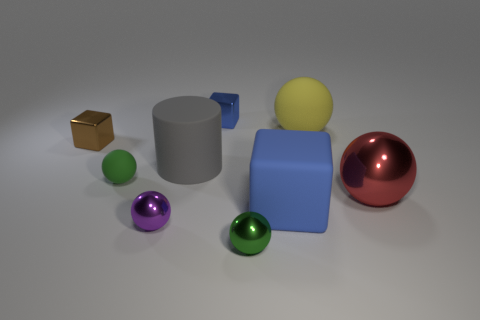Subtract all big blue matte cubes. How many cubes are left? 2 Subtract all blue blocks. How many blocks are left? 1 Subtract all cylinders. How many objects are left? 8 Subtract 5 spheres. How many spheres are left? 0 Subtract all green cylinders. How many brown blocks are left? 1 Subtract all small purple metal balls. Subtract all rubber cylinders. How many objects are left? 7 Add 5 large gray cylinders. How many large gray cylinders are left? 6 Add 8 small brown shiny objects. How many small brown shiny objects exist? 9 Subtract 0 red cubes. How many objects are left? 9 Subtract all brown spheres. Subtract all red cubes. How many spheres are left? 5 